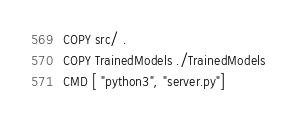Convert code to text. <code><loc_0><loc_0><loc_500><loc_500><_Dockerfile_>COPY src/ .
COPY TrainedModels ./TrainedModels
CMD [ "python3", "server.py"]</code> 